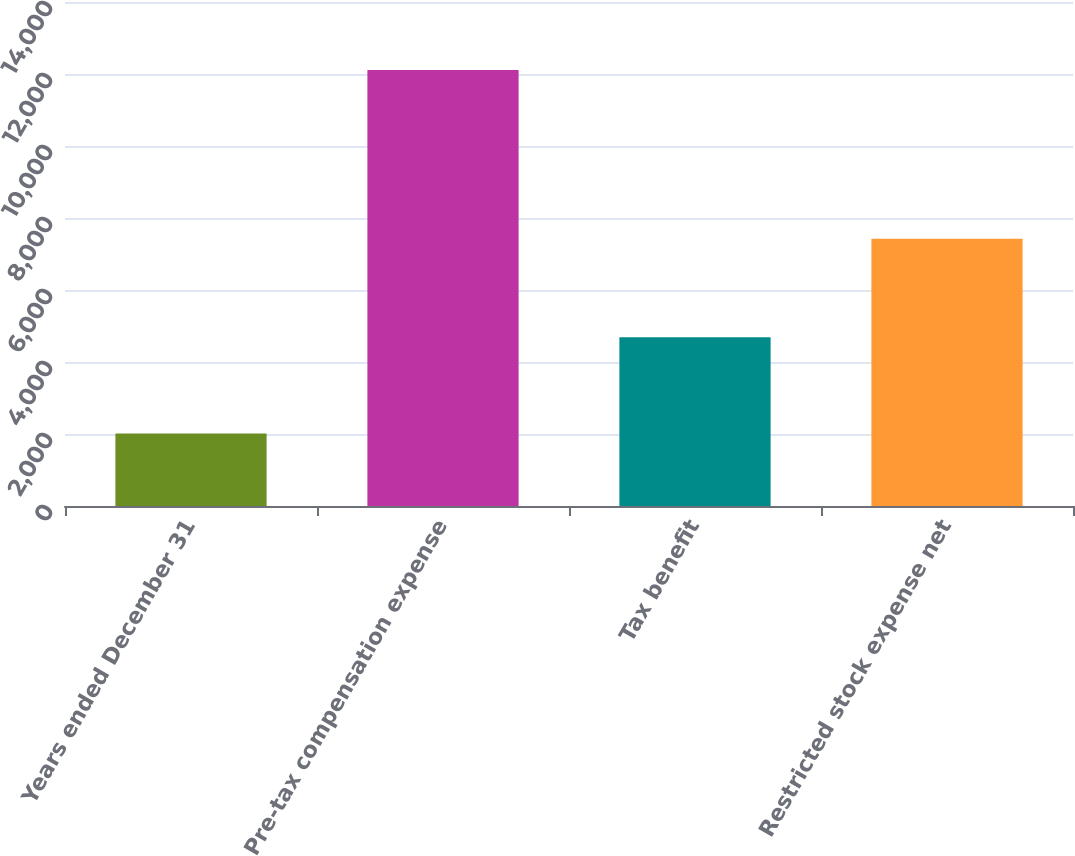Convert chart to OTSL. <chart><loc_0><loc_0><loc_500><loc_500><bar_chart><fcel>Years ended December 31<fcel>Pre-tax compensation expense<fcel>Tax benefit<fcel>Restricted stock expense net<nl><fcel>2015<fcel>12110<fcel>4687<fcel>7423<nl></chart> 